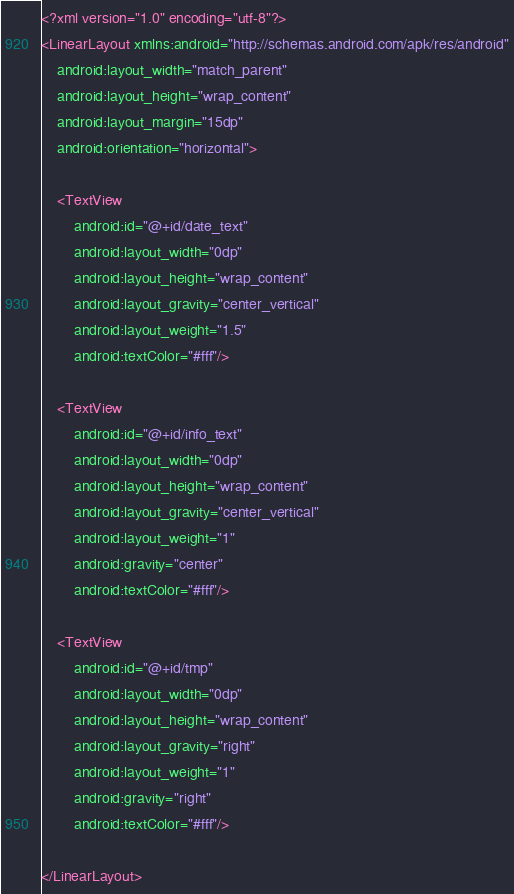Convert code to text. <code><loc_0><loc_0><loc_500><loc_500><_XML_><?xml version="1.0" encoding="utf-8"?>
<LinearLayout xmlns:android="http://schemas.android.com/apk/res/android"
    android:layout_width="match_parent"
    android:layout_height="wrap_content"
    android:layout_margin="15dp"
    android:orientation="horizontal">

    <TextView
        android:id="@+id/date_text"
        android:layout_width="0dp"
        android:layout_height="wrap_content"
        android:layout_gravity="center_vertical"
        android:layout_weight="1.5"
        android:textColor="#fff"/>

    <TextView
        android:id="@+id/info_text"
        android:layout_width="0dp"
        android:layout_height="wrap_content"
        android:layout_gravity="center_vertical"
        android:layout_weight="1"
        android:gravity="center"
        android:textColor="#fff"/>

    <TextView
        android:id="@+id/tmp"
        android:layout_width="0dp"
        android:layout_height="wrap_content"
        android:layout_gravity="right"
        android:layout_weight="1"
        android:gravity="right"
        android:textColor="#fff"/>

</LinearLayout></code> 